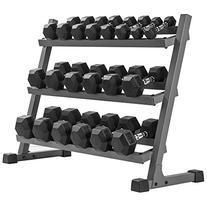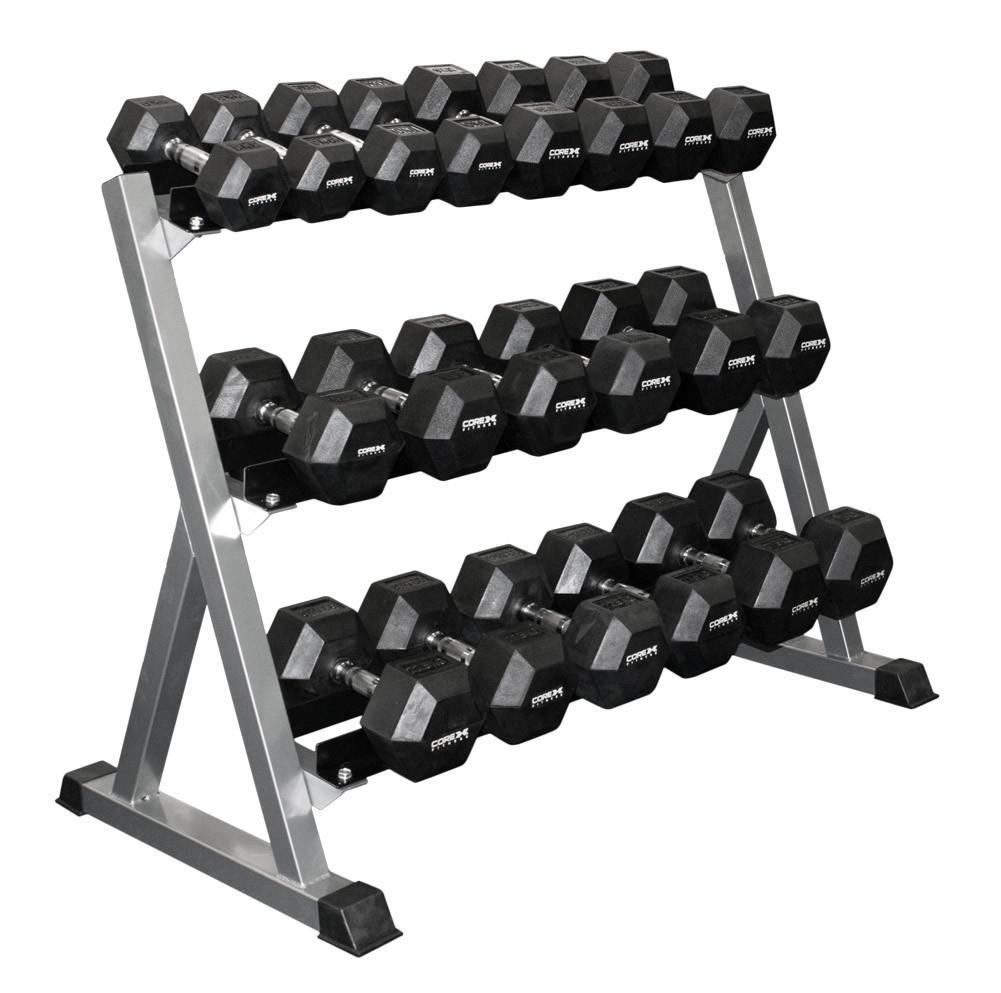The first image is the image on the left, the second image is the image on the right. Examine the images to the left and right. Is the description "There are six rows on weights with three rows in each image, and each image's rows of weights are facing opposite directions." accurate? Answer yes or no. Yes. The first image is the image on the left, the second image is the image on the right. For the images displayed, is the sentence "One rack has three tiers to hold dumbbells, and the other rack has only two shelves for weights." factually correct? Answer yes or no. No. 